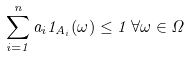<formula> <loc_0><loc_0><loc_500><loc_500>\sum _ { i = 1 } ^ { n } a _ { i } { 1 } _ { A _ { i } } ( \omega ) \leq 1 \, \forall \omega \in \Omega</formula> 